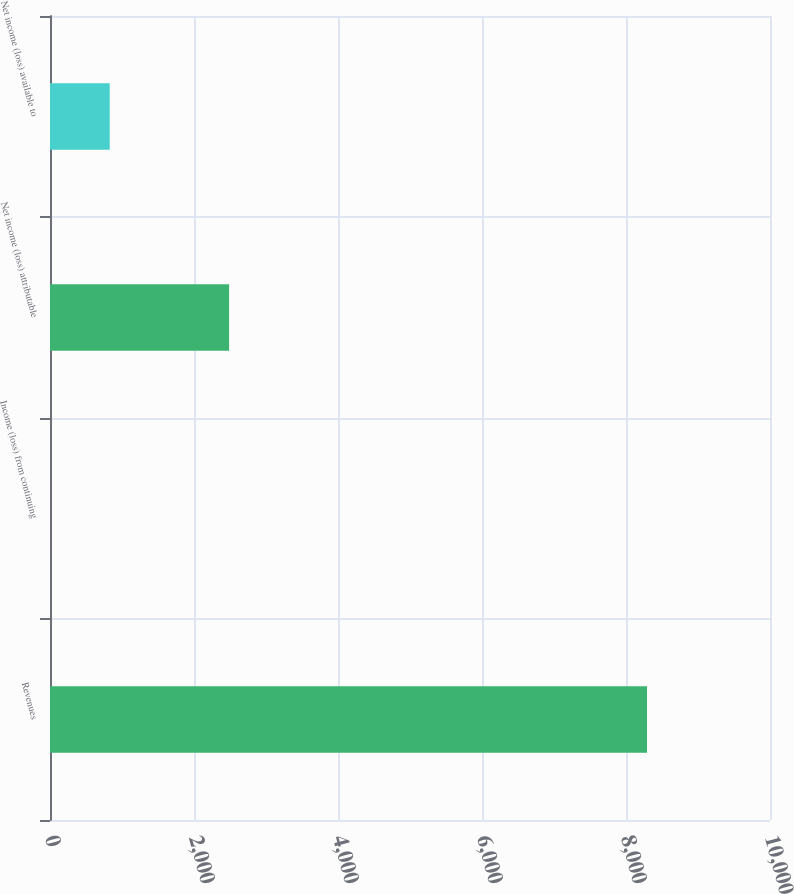Convert chart. <chart><loc_0><loc_0><loc_500><loc_500><bar_chart><fcel>Revenues<fcel>Income (loss) from continuing<fcel>Net income (loss) attributable<fcel>Net income (loss) available to<nl><fcel>8292<fcel>0.28<fcel>2487.79<fcel>829.45<nl></chart> 